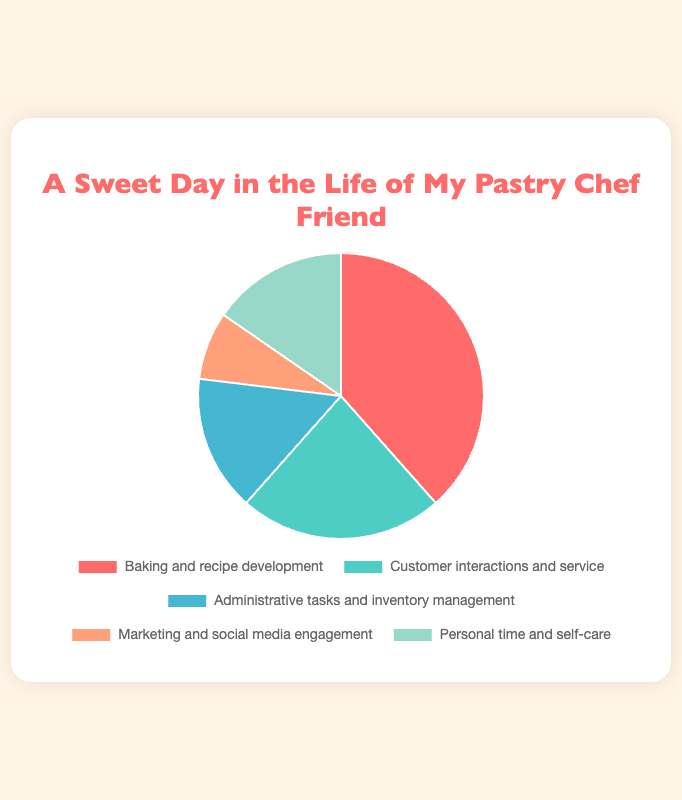What activity takes up the most time in the pastry chef's day? The visual information from the pie chart shows that "Baking and recipe development" has the largest segment.
Answer: Baking and recipe development Which two activities together take up the least amount of time? The segments for "Marketing and social media engagement" (1 hour) and "Administrative tasks and inventory management" (2 hours) together total 3 hours, which is the smallest combined amount of time.
Answer: Marketing and social media engagement, Administrative tasks and inventory management What is the total time spent on activities related to direct interaction with customers and marketing? Sum the time spent on "Customer interactions and service" (3 hours) and "Marketing and social media engagement" (1 hour). 3 + 1 = 4 hours.
Answer: 4 hours Which activity uses less time: "Administrative tasks and inventory management" or "Customer interactions and service"? By comparing the segments, "Administrative tasks and inventory management" uses 2 hours, and "Customer interactions and service" uses 3 hours.
Answer: Administrative tasks and inventory management What is the difference in time spent between the most and least time-consuming activities? The most time-consuming activity is "Baking and recipe development" at 5 hours, and the least is "Marketing and social media engagement" at 1 hour. The difference is 5 - 1 = 4 hours.
Answer: 4 hours How many hours are spent on activities indirectly related to the business (marketing, administrative tasks, etc.)? Sum the time spent on "Administrative tasks and inventory management" (2 hours) and "Marketing and social media engagement" (1 hour). 2 + 1 = 3 hours.
Answer: 3 hours If the total time available is 24 hours, what percentage of the day is spent on personal time and self-care? The chef spends 2 hours on personal time and self-care out of a 24-hour day. 2/24 * 100 = 8.33%.
Answer: 8.33% Which activity represented by the color green corresponds to the amount of time spent? The pie chart shows that the green segment corresponds to "Customer interactions and service," which takes 3 hours.
Answer: Customer interactions and service What is the combined time spent on both "Personal time and self-care" and "Baking and recipe development"? Sum the hours for "Personal time and self-care" (2 hours) and "Baking and recipe development" (5 hours). 2 + 5 = 7 hours.
Answer: 7 hours 